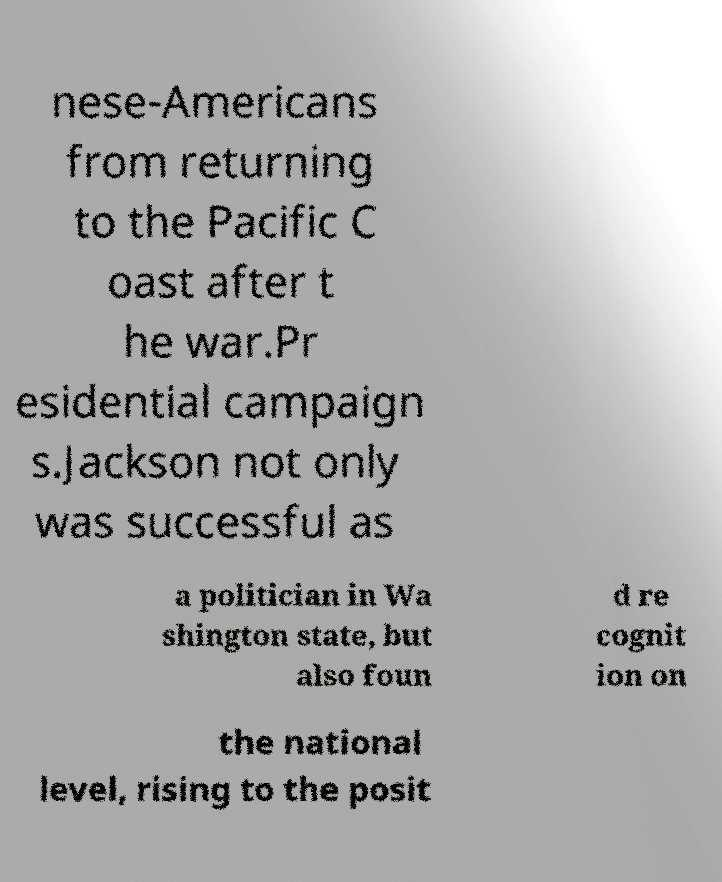What messages or text are displayed in this image? I need them in a readable, typed format. nese-Americans from returning to the Pacific C oast after t he war.Pr esidential campaign s.Jackson not only was successful as a politician in Wa shington state, but also foun d re cognit ion on the national level, rising to the posit 